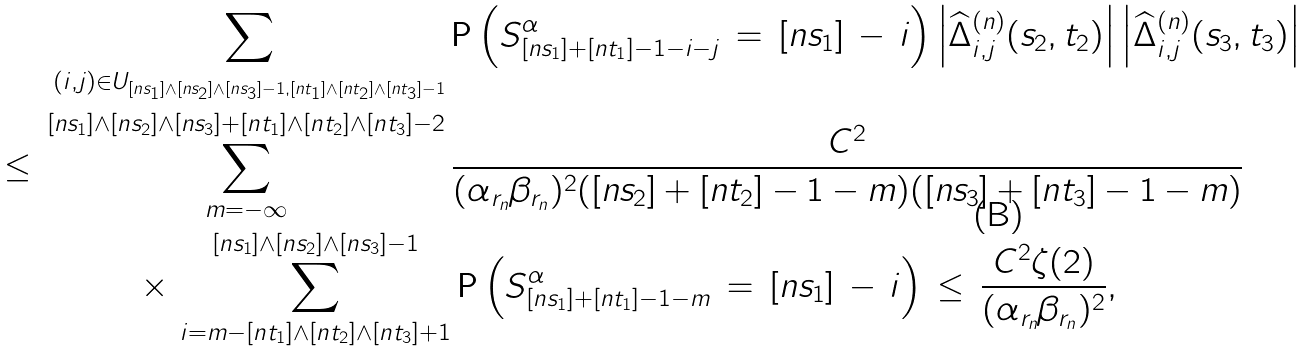Convert formula to latex. <formula><loc_0><loc_0><loc_500><loc_500>\, \sum _ { ( i , j ) \in U _ { [ n s _ { 1 } ] \land [ n s _ { 2 } ] \land [ n s _ { 3 } ] - 1 , [ n t _ { 1 } ] \land [ n t _ { 2 } ] \land [ n t _ { 3 } ] - 1 } } \, & { \mathsf P } \left ( S ^ { \alpha } _ { [ n s _ { 1 } ] + [ n t _ { 1 } ] - 1 - i - j } \, = \, [ n s _ { 1 } ] \, - \, i \right ) \left | \widehat { \Delta } ^ { ( n ) } _ { i , j } ( s _ { 2 } , t _ { 2 } ) \right | \left | \widehat { \Delta } ^ { ( n ) } _ { i , j } ( s _ { 3 } , t _ { 3 } ) \right | \\ \leq \, \sum _ { m = - \infty } ^ { [ n s _ { 1 } ] \land [ n s _ { 2 } ] \land [ n s _ { 3 } ] + [ n t _ { 1 } ] \land [ n t _ { 2 } ] \land [ n t _ { 3 } ] - 2 } \, & \frac { C ^ { 2 } } { ( \alpha _ { r _ { n } } \beta _ { r _ { n } } ) ^ { 2 } ( [ n s _ { 2 } ] + [ n t _ { 2 } ] - 1 - m ) ( [ n s _ { 3 } ] + [ n t _ { 3 } ] - 1 - m ) } \\ \times \, \sum _ { i = m - [ n t _ { 1 } ] \land [ n t _ { 2 } ] \land [ n t _ { 3 } ] + 1 } ^ { [ n s _ { 1 } ] \land [ n s _ { 2 } ] \land [ n s _ { 3 } ] - 1 } & \, { \mathsf P } \left ( S ^ { \alpha } _ { [ n s _ { 1 } ] + [ n t _ { 1 } ] - 1 - m } \, = \, [ n s _ { 1 } ] \, - \, i \right ) \, \leq \, \frac { C ^ { 2 } \zeta ( 2 ) } { ( \alpha _ { r _ { n } } \beta _ { r _ { n } } ) ^ { 2 } } ,</formula> 